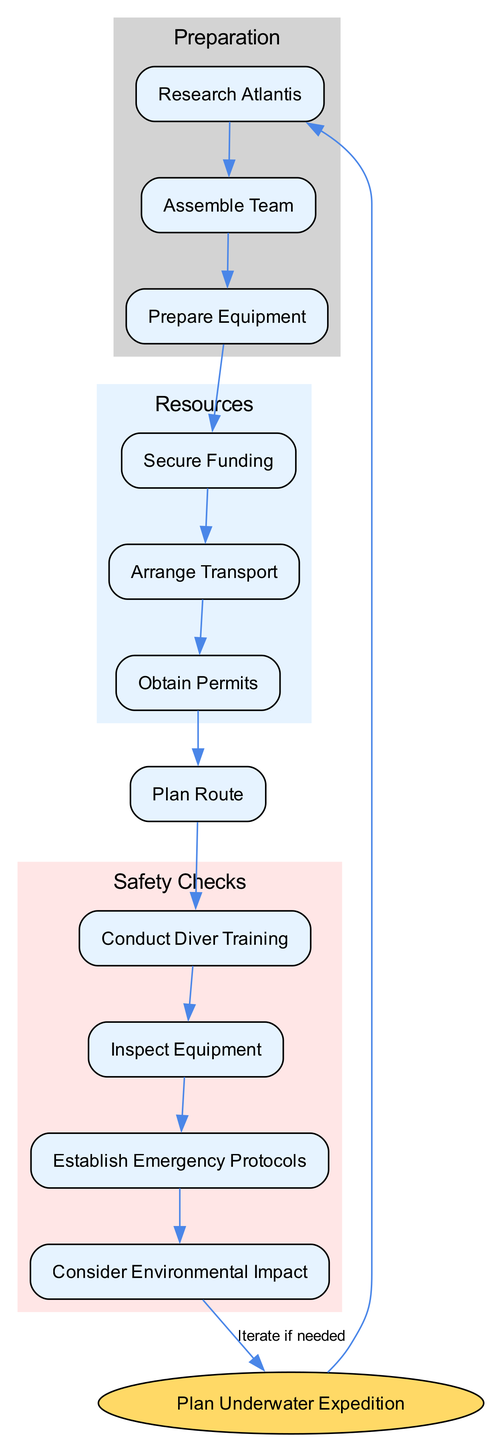What is the first step in the expedition planning? The first step in the expedition planning, as indicated by the diagram, is to "Research Atlantis." This forms the starting point of the preparation phase.
Answer: Research Atlantis How many main preparation steps are outlined? The diagram outlines three main preparation steps: "Research Atlantis," "Assemble Team," and "Prepare Equipment." Counting these steps gives a total of three main preparation steps.
Answer: 3 What type of funding is included in the resources section? The diagram specifies two types of funding: "Sponsorship" and "Crowdfunding." These are the ways to secure financial support for the expedition.
Answer: Sponsorship, Crowdfunding Which node directly connects to "Obtain Permits"? "Arrange Transport" is the node that directly connects to "Obtain Permits." The flow of the diagram indicates this direct relationship in the resource section.
Answer: Arrange Transport What are the two main categories of safety checks? The two main categories of safety checks indicated in the diagram are "Conduct Diver Training" and "Established Emergency Protocols." Both these checks ensure the safety of divers during the expedition.
Answer: Conduct Diver Training, Establish Emergency Protocols How does the "Prepare Equipment" relate to "Secure Funding"? "Prepare Equipment" is a step that is dependent on having "Secure Funding." According to the flowchart, funding needs to be secured before preparing the necessary equipment for the expedition.
Answer: Prepare Equipment depends on Secure Funding What influences the need to iterate back to "Plan Underwater Expedition"? The "Consider Environmental Impact" step may lead back to the main planning node if further actions or adjustments are needed based on environmental assessments conducted during the safety checks.
Answer: Environmental Considerations How many nodes represent team assembly roles? There are four nodes representing team assembly roles: "Mission Leader," "Diving Experts," "Scientists," and "Support Crew." These roles are crucial for the expedition's success as shown in the team assembly section.
Answer: 4 What is evaluated during the emergency protocols check? The "Establish Emergency Protocols" step includes the evaluation of "Evacuation Plan" and "Medical Support," ensuring that the expedition can respond effectively to emergencies.
Answer: Evacuation Plan, Medical Support 